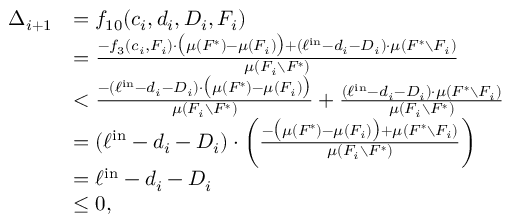Convert formula to latex. <formula><loc_0><loc_0><loc_500><loc_500>\begin{array} { r l } { \Delta _ { i + 1 } } & { = f _ { 1 0 } ( c _ { i } , d _ { i } , D _ { i } , F _ { i } ) } & { = \frac { - f _ { 3 } ( c _ { i } , F _ { i } ) \cdot \left ( \mu ( F ^ { * } ) - \mu ( F _ { i } ) \right ) + ( \ell ^ { i n } - d _ { i } - D _ { i } ) \cdot \mu ( F ^ { * } \ F _ { i } ) } { \mu ( F _ { i } \ F ^ { * } ) } } & { < \frac { - ( \ell ^ { i n } - d _ { i } - D _ { i } ) \cdot \left ( \mu ( F ^ { * } ) - \mu ( F _ { i } ) \right ) } { \mu ( F _ { i } \ F ^ { * } ) } + \frac { ( \ell ^ { i n } - d _ { i } - D _ { i } ) \cdot \mu ( F ^ { * } \ F _ { i } ) } { \mu ( F _ { i } \ F ^ { * } ) } } & { = ( \ell ^ { i n } - d _ { i } - D _ { i } ) \cdot \left ( \frac { - \left ( \mu ( F ^ { * } ) - \mu ( F _ { i } ) \right ) + \mu ( F ^ { * } \ F _ { i } ) } { \mu ( F _ { i } \ F ^ { * } ) } \right ) } & { = \ell ^ { i n } - d _ { i } - D _ { i } } & { \leq 0 , } \end{array}</formula> 